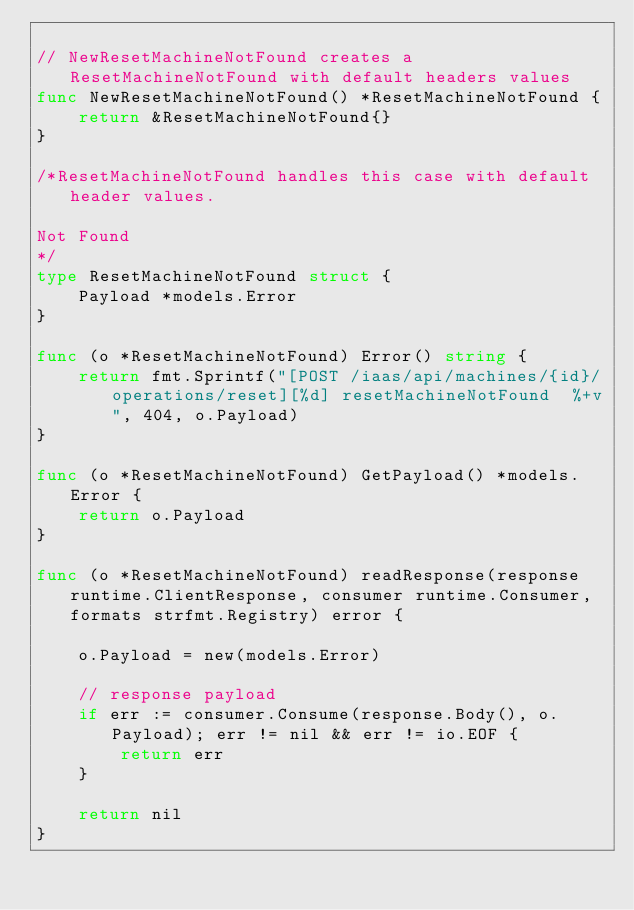Convert code to text. <code><loc_0><loc_0><loc_500><loc_500><_Go_>
// NewResetMachineNotFound creates a ResetMachineNotFound with default headers values
func NewResetMachineNotFound() *ResetMachineNotFound {
	return &ResetMachineNotFound{}
}

/*ResetMachineNotFound handles this case with default header values.

Not Found
*/
type ResetMachineNotFound struct {
	Payload *models.Error
}

func (o *ResetMachineNotFound) Error() string {
	return fmt.Sprintf("[POST /iaas/api/machines/{id}/operations/reset][%d] resetMachineNotFound  %+v", 404, o.Payload)
}

func (o *ResetMachineNotFound) GetPayload() *models.Error {
	return o.Payload
}

func (o *ResetMachineNotFound) readResponse(response runtime.ClientResponse, consumer runtime.Consumer, formats strfmt.Registry) error {

	o.Payload = new(models.Error)

	// response payload
	if err := consumer.Consume(response.Body(), o.Payload); err != nil && err != io.EOF {
		return err
	}

	return nil
}
</code> 